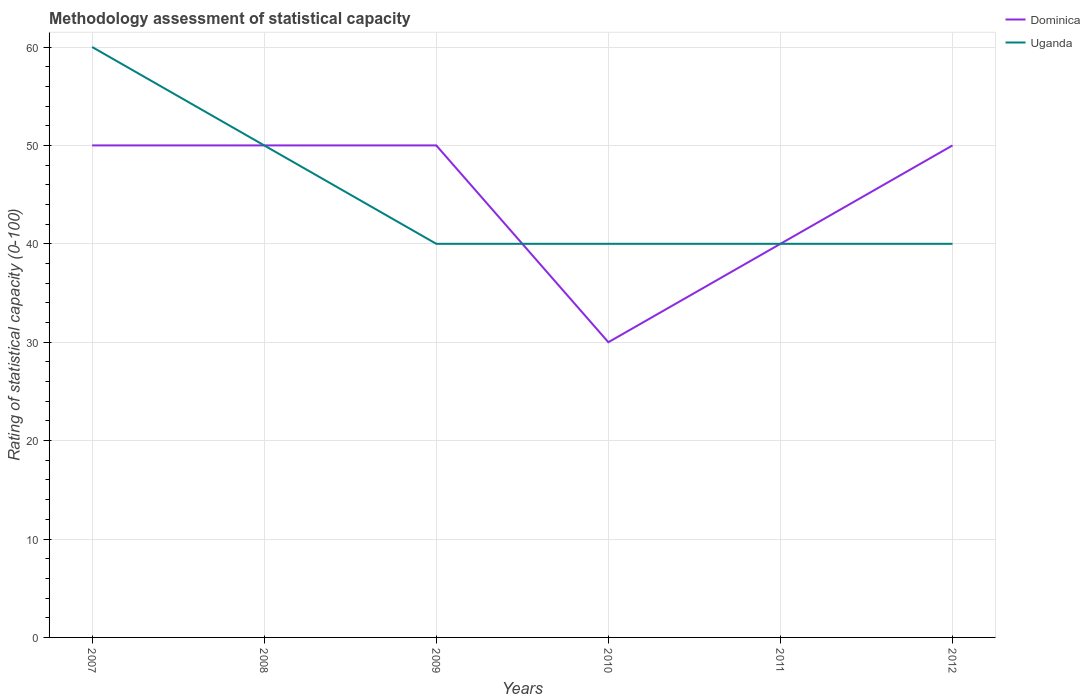Does the line corresponding to Uganda intersect with the line corresponding to Dominica?
Make the answer very short. Yes. Across all years, what is the maximum rating of statistical capacity in Uganda?
Make the answer very short. 40. What is the difference between the highest and the lowest rating of statistical capacity in Dominica?
Give a very brief answer. 4. Is the rating of statistical capacity in Uganda strictly greater than the rating of statistical capacity in Dominica over the years?
Offer a very short reply. No. How many years are there in the graph?
Provide a succinct answer. 6. Are the values on the major ticks of Y-axis written in scientific E-notation?
Offer a terse response. No. Does the graph contain any zero values?
Your answer should be very brief. No. Does the graph contain grids?
Provide a short and direct response. Yes. Where does the legend appear in the graph?
Your response must be concise. Top right. How are the legend labels stacked?
Offer a very short reply. Vertical. What is the title of the graph?
Offer a very short reply. Methodology assessment of statistical capacity. What is the label or title of the X-axis?
Your response must be concise. Years. What is the label or title of the Y-axis?
Offer a very short reply. Rating of statistical capacity (0-100). What is the Rating of statistical capacity (0-100) of Dominica in 2007?
Provide a succinct answer. 50. What is the Rating of statistical capacity (0-100) of Uganda in 2007?
Offer a terse response. 60. What is the Rating of statistical capacity (0-100) of Dominica in 2008?
Give a very brief answer. 50. What is the Rating of statistical capacity (0-100) of Uganda in 2008?
Ensure brevity in your answer.  50. What is the Rating of statistical capacity (0-100) in Dominica in 2009?
Your response must be concise. 50. What is the Rating of statistical capacity (0-100) in Uganda in 2009?
Ensure brevity in your answer.  40. What is the Rating of statistical capacity (0-100) of Uganda in 2010?
Provide a succinct answer. 40. What is the Rating of statistical capacity (0-100) of Dominica in 2012?
Your answer should be compact. 50. Across all years, what is the minimum Rating of statistical capacity (0-100) of Uganda?
Make the answer very short. 40. What is the total Rating of statistical capacity (0-100) of Dominica in the graph?
Ensure brevity in your answer.  270. What is the total Rating of statistical capacity (0-100) in Uganda in the graph?
Offer a very short reply. 270. What is the difference between the Rating of statistical capacity (0-100) of Dominica in 2007 and that in 2008?
Offer a very short reply. 0. What is the difference between the Rating of statistical capacity (0-100) in Dominica in 2007 and that in 2011?
Offer a very short reply. 10. What is the difference between the Rating of statistical capacity (0-100) of Uganda in 2007 and that in 2011?
Offer a terse response. 20. What is the difference between the Rating of statistical capacity (0-100) of Dominica in 2008 and that in 2009?
Ensure brevity in your answer.  0. What is the difference between the Rating of statistical capacity (0-100) in Dominica in 2008 and that in 2011?
Ensure brevity in your answer.  10. What is the difference between the Rating of statistical capacity (0-100) in Dominica in 2008 and that in 2012?
Provide a succinct answer. 0. What is the difference between the Rating of statistical capacity (0-100) in Uganda in 2008 and that in 2012?
Offer a very short reply. 10. What is the difference between the Rating of statistical capacity (0-100) in Uganda in 2009 and that in 2010?
Your response must be concise. 0. What is the difference between the Rating of statistical capacity (0-100) of Uganda in 2009 and that in 2011?
Offer a terse response. 0. What is the difference between the Rating of statistical capacity (0-100) of Uganda in 2010 and that in 2012?
Offer a terse response. 0. What is the difference between the Rating of statistical capacity (0-100) in Dominica in 2011 and that in 2012?
Ensure brevity in your answer.  -10. What is the difference between the Rating of statistical capacity (0-100) of Uganda in 2011 and that in 2012?
Your response must be concise. 0. What is the difference between the Rating of statistical capacity (0-100) in Dominica in 2007 and the Rating of statistical capacity (0-100) in Uganda in 2010?
Your answer should be compact. 10. What is the difference between the Rating of statistical capacity (0-100) in Dominica in 2007 and the Rating of statistical capacity (0-100) in Uganda in 2011?
Provide a short and direct response. 10. What is the difference between the Rating of statistical capacity (0-100) in Dominica in 2007 and the Rating of statistical capacity (0-100) in Uganda in 2012?
Offer a very short reply. 10. What is the difference between the Rating of statistical capacity (0-100) of Dominica in 2008 and the Rating of statistical capacity (0-100) of Uganda in 2010?
Give a very brief answer. 10. What is the difference between the Rating of statistical capacity (0-100) of Dominica in 2008 and the Rating of statistical capacity (0-100) of Uganda in 2012?
Offer a terse response. 10. What is the difference between the Rating of statistical capacity (0-100) in Dominica in 2009 and the Rating of statistical capacity (0-100) in Uganda in 2010?
Ensure brevity in your answer.  10. What is the difference between the Rating of statistical capacity (0-100) in Dominica in 2011 and the Rating of statistical capacity (0-100) in Uganda in 2012?
Offer a very short reply. 0. What is the average Rating of statistical capacity (0-100) in Dominica per year?
Offer a very short reply. 45. In the year 2011, what is the difference between the Rating of statistical capacity (0-100) in Dominica and Rating of statistical capacity (0-100) in Uganda?
Ensure brevity in your answer.  0. What is the ratio of the Rating of statistical capacity (0-100) in Dominica in 2007 to that in 2008?
Make the answer very short. 1. What is the ratio of the Rating of statistical capacity (0-100) of Uganda in 2007 to that in 2009?
Your response must be concise. 1.5. What is the ratio of the Rating of statistical capacity (0-100) of Uganda in 2007 to that in 2010?
Keep it short and to the point. 1.5. What is the ratio of the Rating of statistical capacity (0-100) in Dominica in 2007 to that in 2012?
Offer a very short reply. 1. What is the ratio of the Rating of statistical capacity (0-100) in Uganda in 2008 to that in 2009?
Your answer should be very brief. 1.25. What is the ratio of the Rating of statistical capacity (0-100) in Dominica in 2008 to that in 2010?
Provide a succinct answer. 1.67. What is the ratio of the Rating of statistical capacity (0-100) in Uganda in 2008 to that in 2010?
Provide a short and direct response. 1.25. What is the ratio of the Rating of statistical capacity (0-100) of Dominica in 2008 to that in 2011?
Offer a terse response. 1.25. What is the ratio of the Rating of statistical capacity (0-100) in Uganda in 2008 to that in 2011?
Offer a terse response. 1.25. What is the ratio of the Rating of statistical capacity (0-100) of Uganda in 2008 to that in 2012?
Provide a short and direct response. 1.25. What is the ratio of the Rating of statistical capacity (0-100) of Dominica in 2009 to that in 2010?
Ensure brevity in your answer.  1.67. What is the ratio of the Rating of statistical capacity (0-100) in Uganda in 2009 to that in 2010?
Your response must be concise. 1. What is the ratio of the Rating of statistical capacity (0-100) in Dominica in 2009 to that in 2011?
Ensure brevity in your answer.  1.25. What is the ratio of the Rating of statistical capacity (0-100) of Uganda in 2009 to that in 2011?
Offer a terse response. 1. What is the ratio of the Rating of statistical capacity (0-100) in Uganda in 2010 to that in 2011?
Your answer should be very brief. 1. What is the ratio of the Rating of statistical capacity (0-100) in Uganda in 2011 to that in 2012?
Ensure brevity in your answer.  1. What is the difference between the highest and the lowest Rating of statistical capacity (0-100) of Dominica?
Provide a succinct answer. 20. 